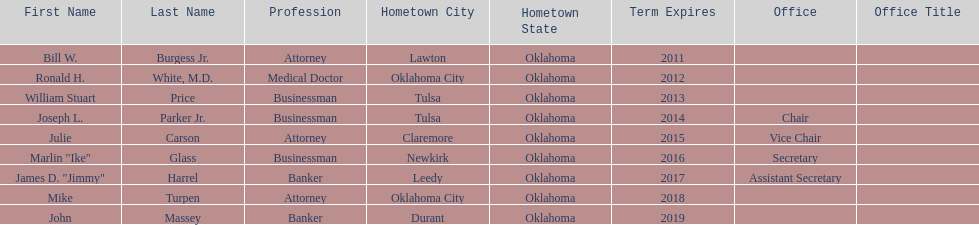What is the total amount of current state regents who are bankers? 2. 